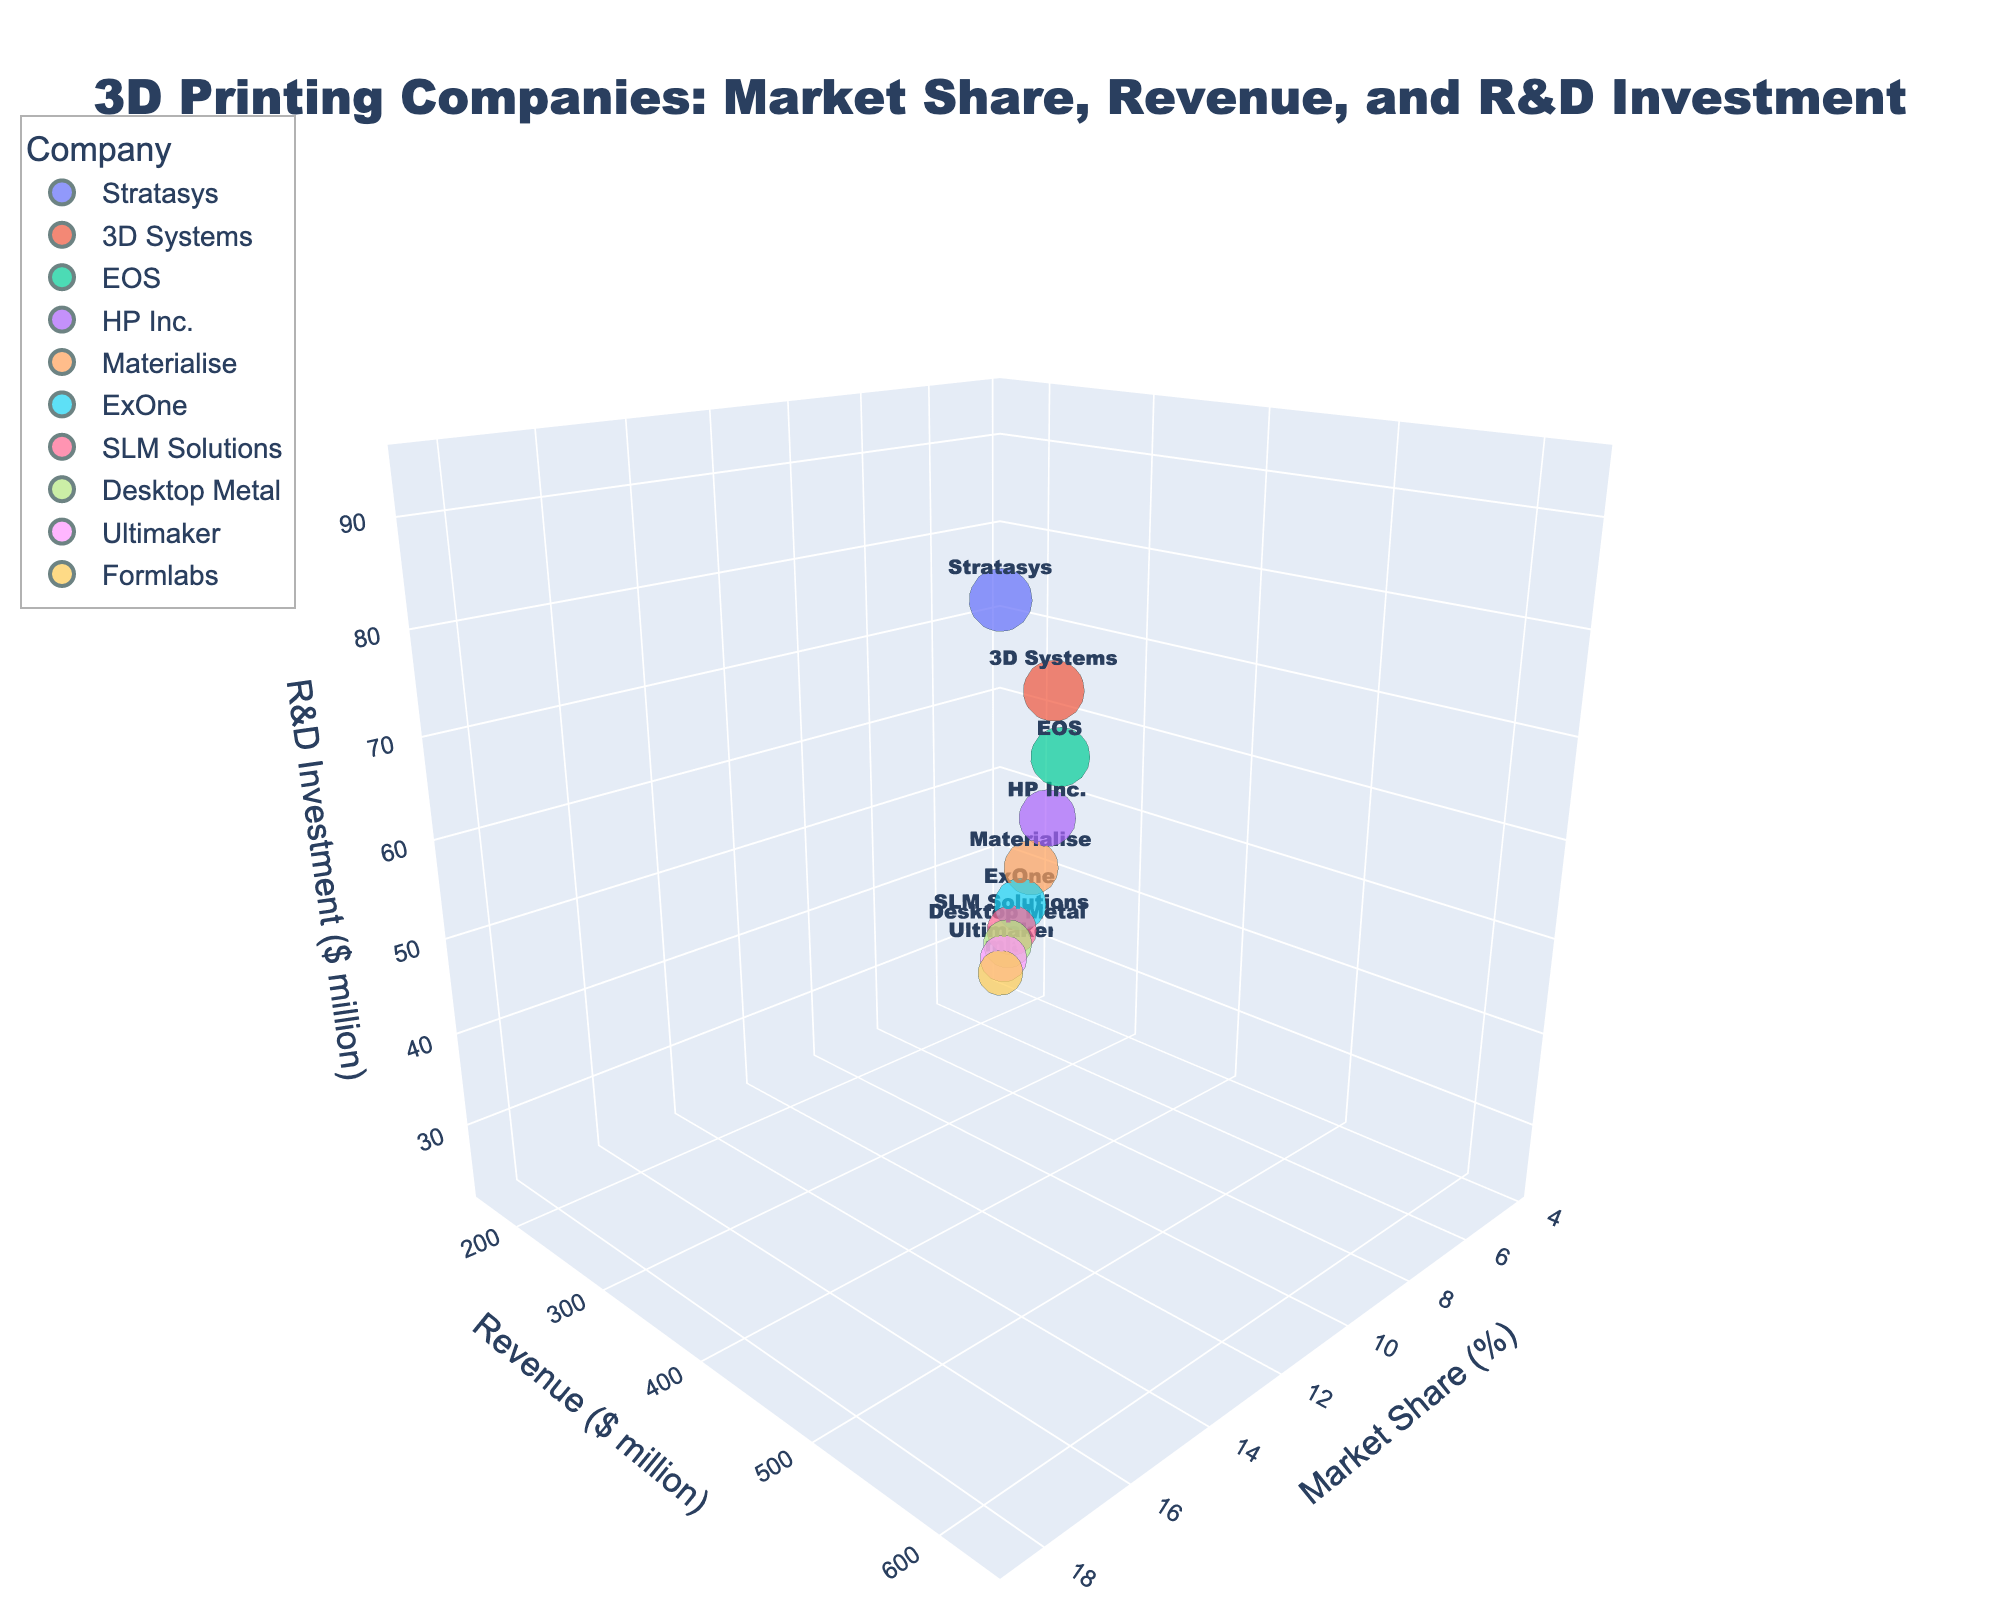What is the title of the figure? The figure's title is usually prominent and located at the top. In this case, it reads "3D Printing Companies: Market Share, Revenue, and R&D Investment".
Answer: 3D Printing Companies: Market Share, Revenue, and R&D Investment Which company has the highest market share? To identify the highest market share, look at the x-axis and find the company with the most rightward position. Stratasys is furthest to the right.
Answer: Stratasys What is the revenue and R&D investment of Ultimaker? Find Ultimaker's bubble, hover, and take note of the y-axis and z-axis values. Ultimaker has a revenue ($ million) of 186 and an R&D investment ($ million) of 28.
Answer: Revenue: 186, R&D Investment: 28 Which company has the smallest bubble size? Bubble size is based on R&D investment. The smallest bubble corresponds to the lowest R&D investment. Formlabs, with 24 million in R&D, has the smallest bubble.
Answer: Formlabs What is the total R&D investment of 3D Systems and EOS combined? Locate both 3D Systems and EOS on the z-axis, then sum their R&D investments. 3D Systems: 83, EOS: 73. Total is 83 + 73 = 156 million dollars.
Answer: 156 Which company has higher revenue, HP Inc. or Materialise? Find both HP Inc. and Materialise on the y-axis and compare their positions. HP Inc. has a revenue of 412 million, and Materialise has a revenue of 345 million. HP Inc. has higher revenue.
Answer: HP Inc What is the average market share of the top three companies by revenue? Identify the top three companies on the y-axis (Stratasys, 3D Systems, EOS) and sum their market shares: 18.5 + 15.2 + 12.8 = 46.5. Divide by 3 to get the average: 46.5 / 3 = 15.5%.
Answer: 15.5% Which company has a greater R&D investment, SLM Solutions or Desktop Metal? Compare the positions of SLM Solutions and Desktop Metal on the z-axis. SLM Solutions: 36 million, Desktop Metal: 32 million. SLM Solutions has a greater R&D investment.
Answer: SLM Solutions Do companies with higher revenue tend to invest more in R&D? Look at the general trend in the 3D bubble chart between the y-axis (revenue) and z-axis (R&D investment). Higher revenue companies generally have higher R&D investments, indicating a positive correlation.
Answer: Yes Which company has the smallest market share and what is its revenue? Look for the leftmost bubble on the x-axis, which represents the smallest market share. Formlabs has the smallest market share with 4.2%, and its revenue is 163 million.
Answer: Formlabs, 163 million 